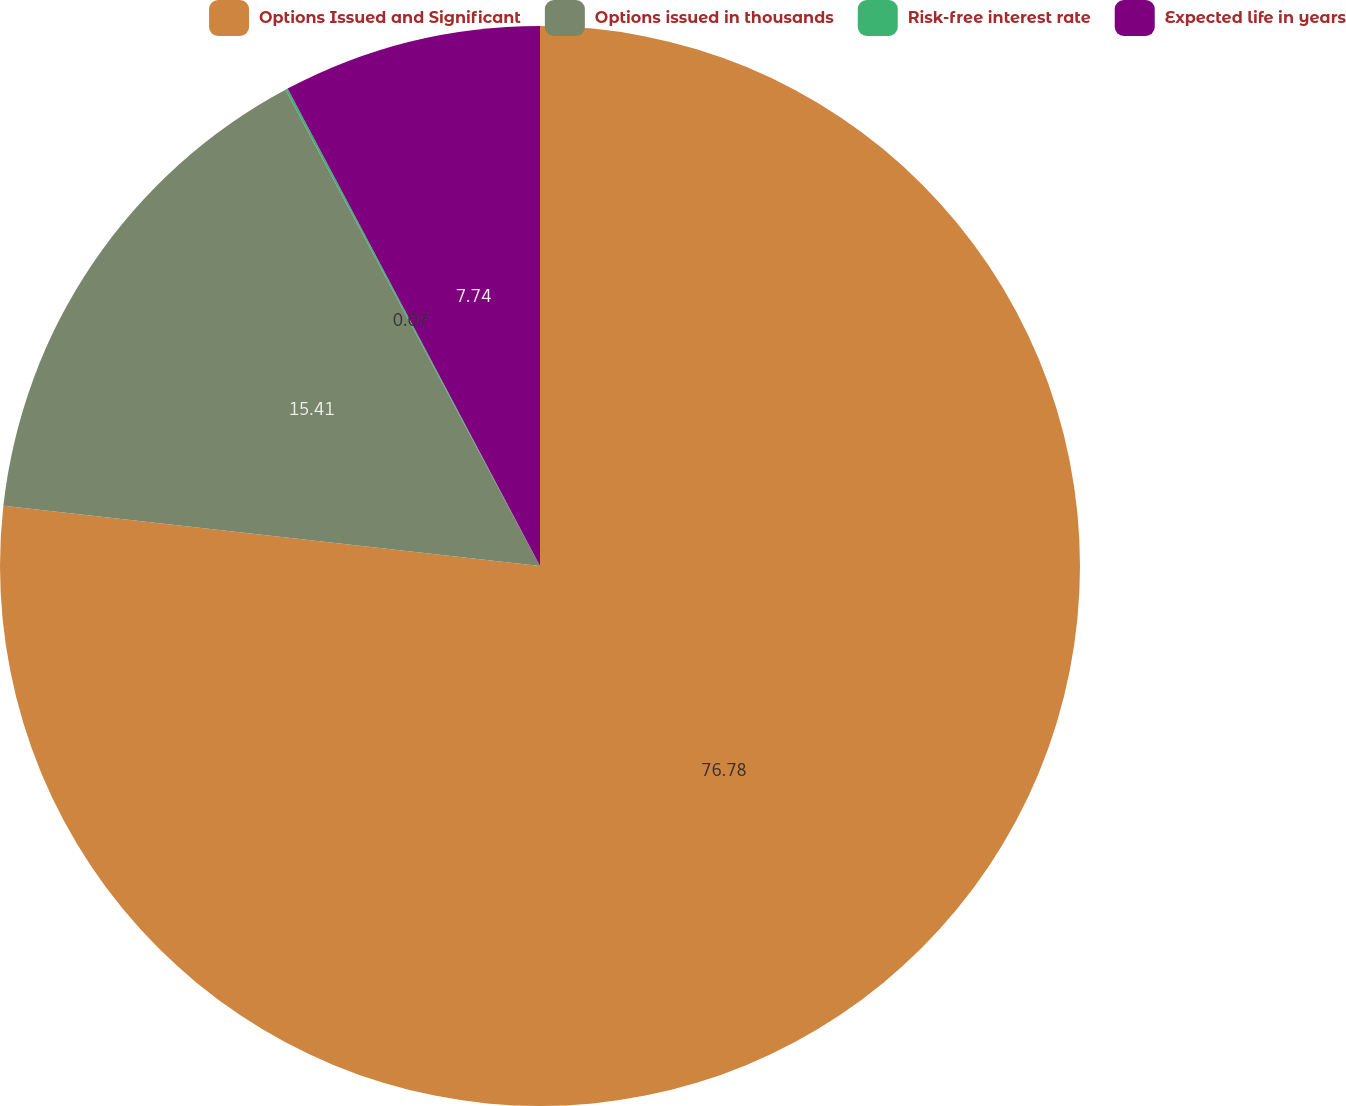Convert chart to OTSL. <chart><loc_0><loc_0><loc_500><loc_500><pie_chart><fcel>Options Issued and Significant<fcel>Options issued in thousands<fcel>Risk-free interest rate<fcel>Expected life in years<nl><fcel>76.77%<fcel>15.41%<fcel>0.07%<fcel>7.74%<nl></chart> 